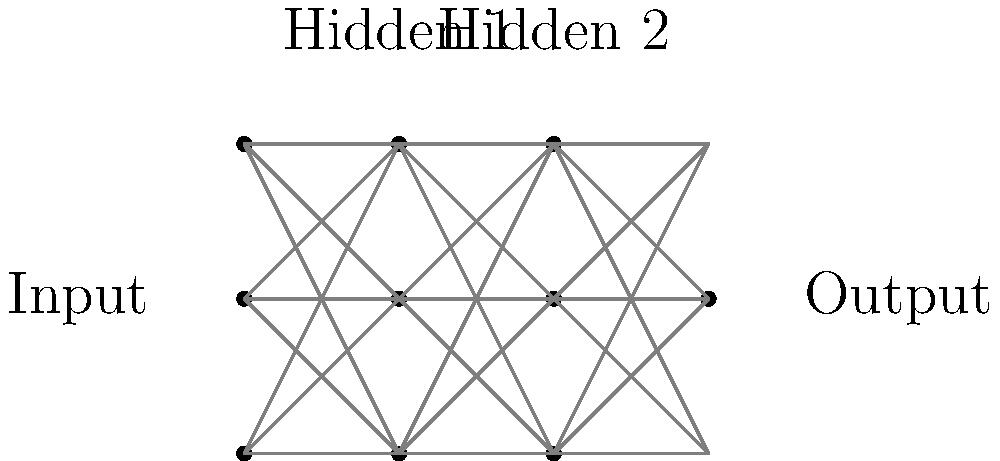As an administrator overseeing computer science education, you're reviewing a machine learning course. The instructor has presented the following neural network architecture diagram. What type of neural network is this, and what key feature distinguishes it from other architectures? To identify this neural network architecture, let's analyze its key components:

1. Structure: The network has multiple layers, including:
   - An input layer with 3 nodes
   - Two hidden layers, each with 3 nodes
   - An output layer with 1 node

2. Connections: Each node in a layer is connected to all nodes in the subsequent layer.

3. Direction of information flow: The connections only move forward from input to output, with no backward or skip connections.

These characteristics point to a specific type of neural network:

- This is a Feedforward Neural Network, more specifically, a Multi-Layer Perceptron (MLP).

The key feature that distinguishes this architecture is:

- The presence of multiple hidden layers between the input and output layers.

This feature allows the network to learn and represent complex, non-linear relationships between inputs and outputs. Each hidden layer can learn increasingly abstract features of the input data, enabling the network to tackle complex problems in various domains such as image recognition, natural language processing, and more.

The multiple hidden layers are what make this a "deep" neural network, as opposed to a simple perceptron which has no hidden layers, or a single-layer network.
Answer: Multi-Layer Perceptron (MLP) with multiple hidden layers 